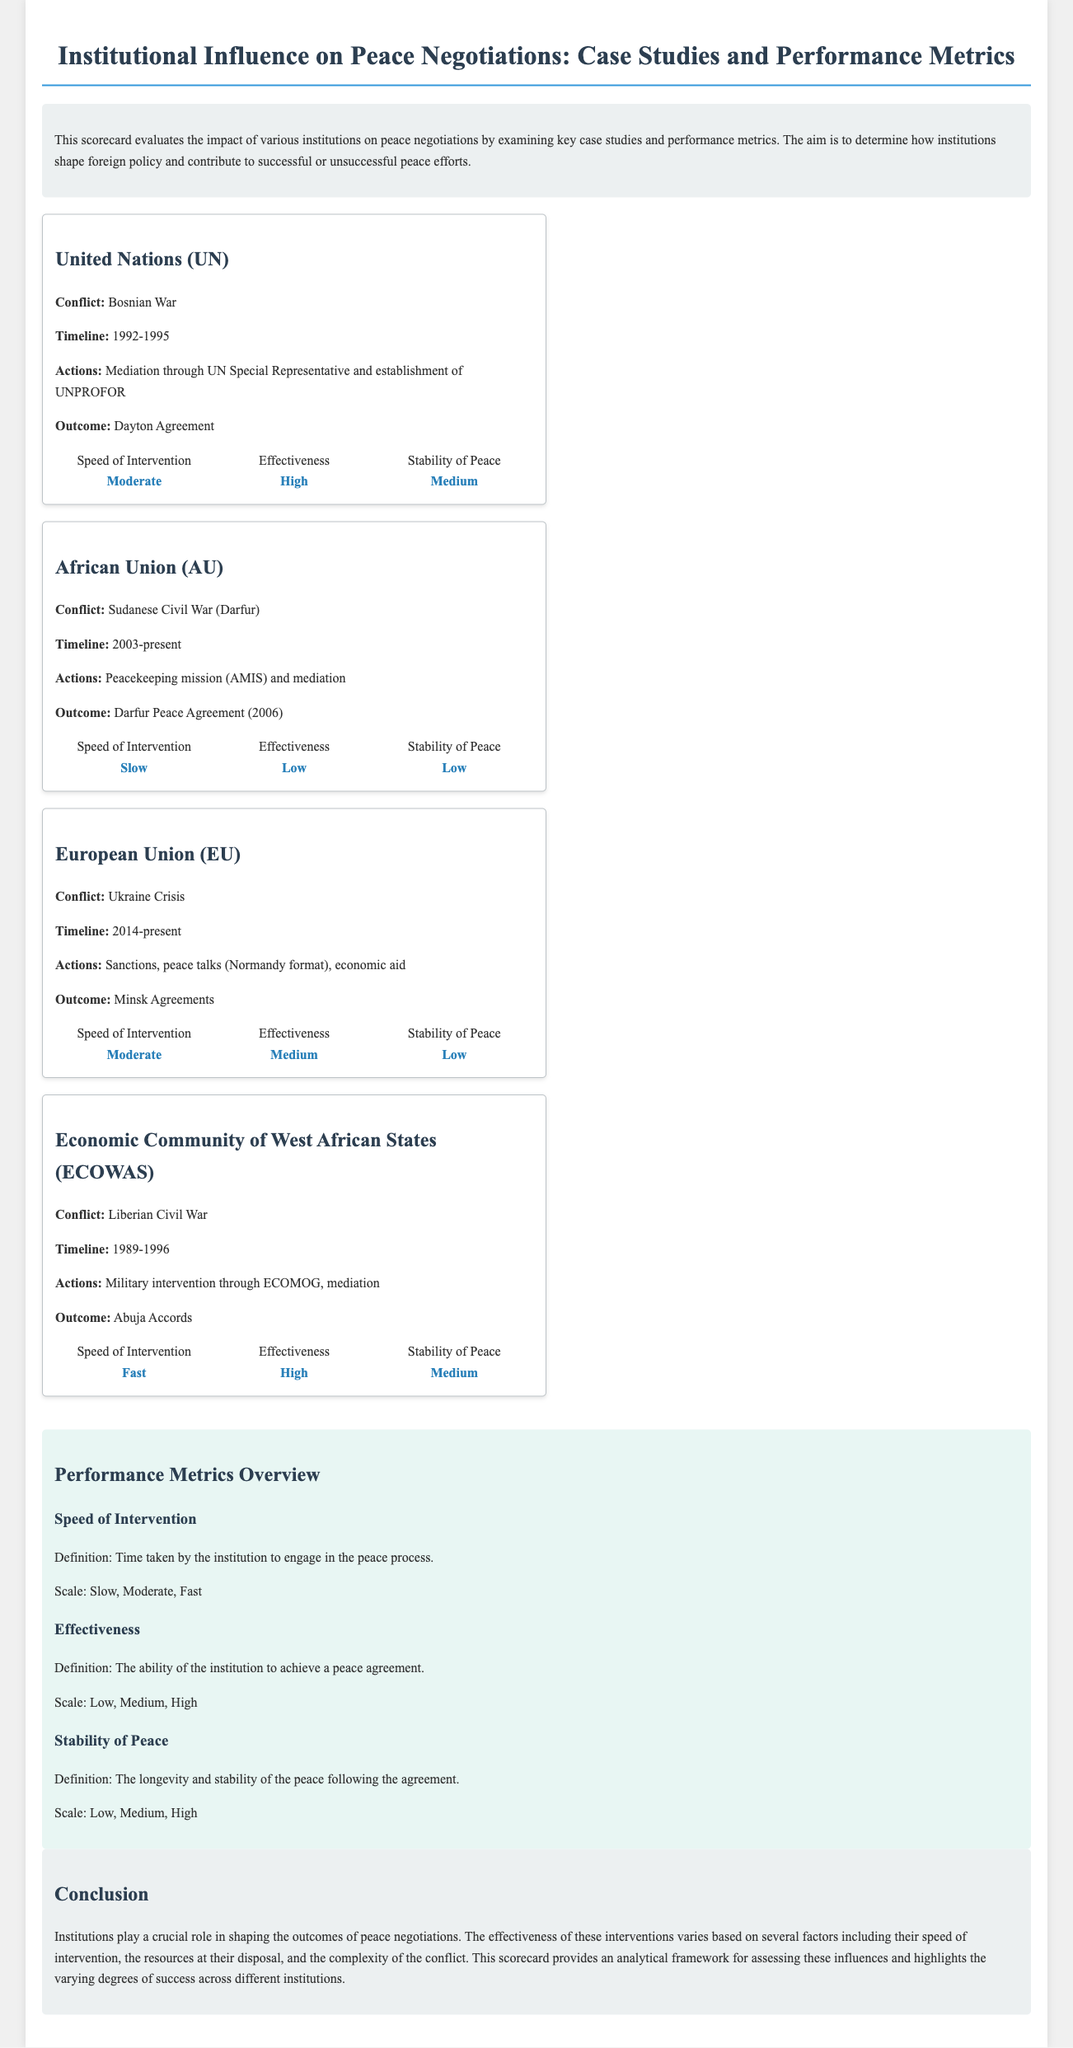What was the conflict involving the United Nations? The document states that the conflict involving the United Nations was the Bosnian War.
Answer: Bosnian War What year did the African Union begin its involvement in the Sudanese Civil War? The document lists the timeline of the African Union's involvement starting from 2003.
Answer: 2003 Which peace agreement is associated with the European Union's actions in the Ukraine Crisis? The document identifies the Minsk Agreements as the outcome of the European Union's actions.
Answer: Minsk Agreements What was the speed of intervention for ECOWAS in the Liberian Civil War? According to the document, the speed of intervention for ECOWAS was categorized as Fast.
Answer: Fast How effective was the African Union in mediating the Darfur conflict? The document rates the effectiveness of the African Union as Low in the context of the Darfur conflict.
Answer: Low What defines 'Stability of Peace' in the performance metrics? The document defines 'Stability of Peace' as the longevity and stability of the peace following the agreement.
Answer: Longevity and stability Which institution had a High effectiveness rating in the scorecard? The document indicates that the Economic Community of West African States had a High effectiveness rating.
Answer: Economic Community of West African States What is the focus of the scorecard? The scorecard evaluates the impact of various institutions on peace negotiations.
Answer: Impact of institutions on peace negotiations What is the timeline of the conflict the African Union is involved in? The document states that the timeline for the Sudanese Civil War is from 2003 to the present.
Answer: 2003-present 